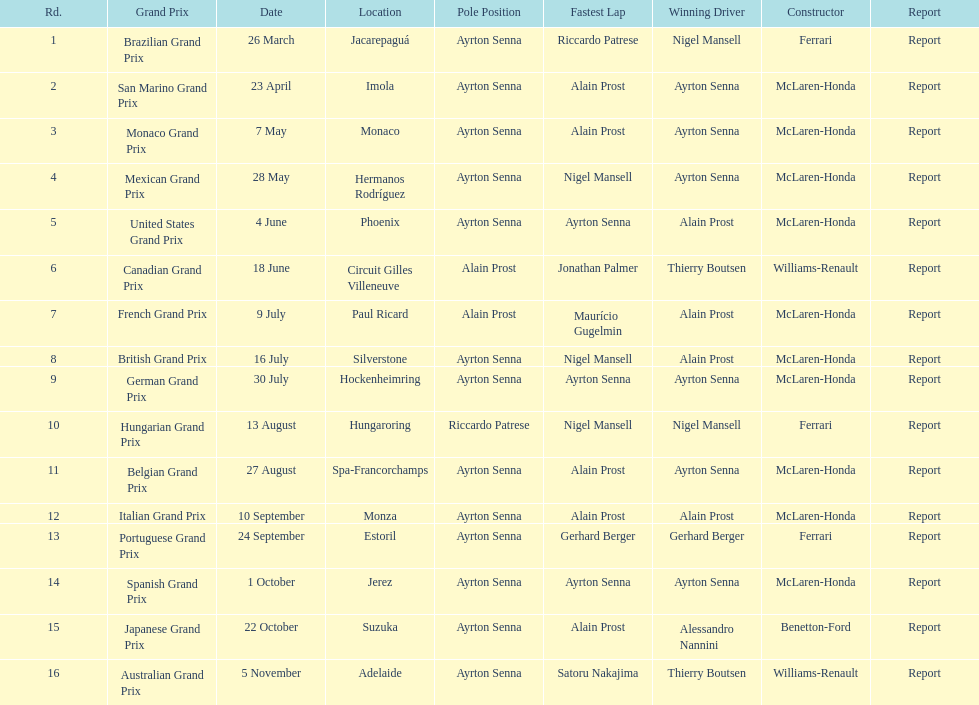Before alain prost won a pole position, how many events transpired? 5. 